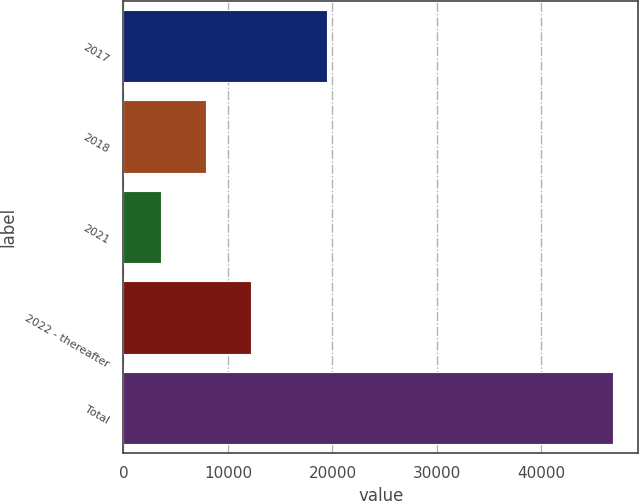Convert chart. <chart><loc_0><loc_0><loc_500><loc_500><bar_chart><fcel>2017<fcel>2018<fcel>2021<fcel>2022 - thereafter<fcel>Total<nl><fcel>19507<fcel>7892.3<fcel>3558<fcel>12226.6<fcel>46901<nl></chart> 